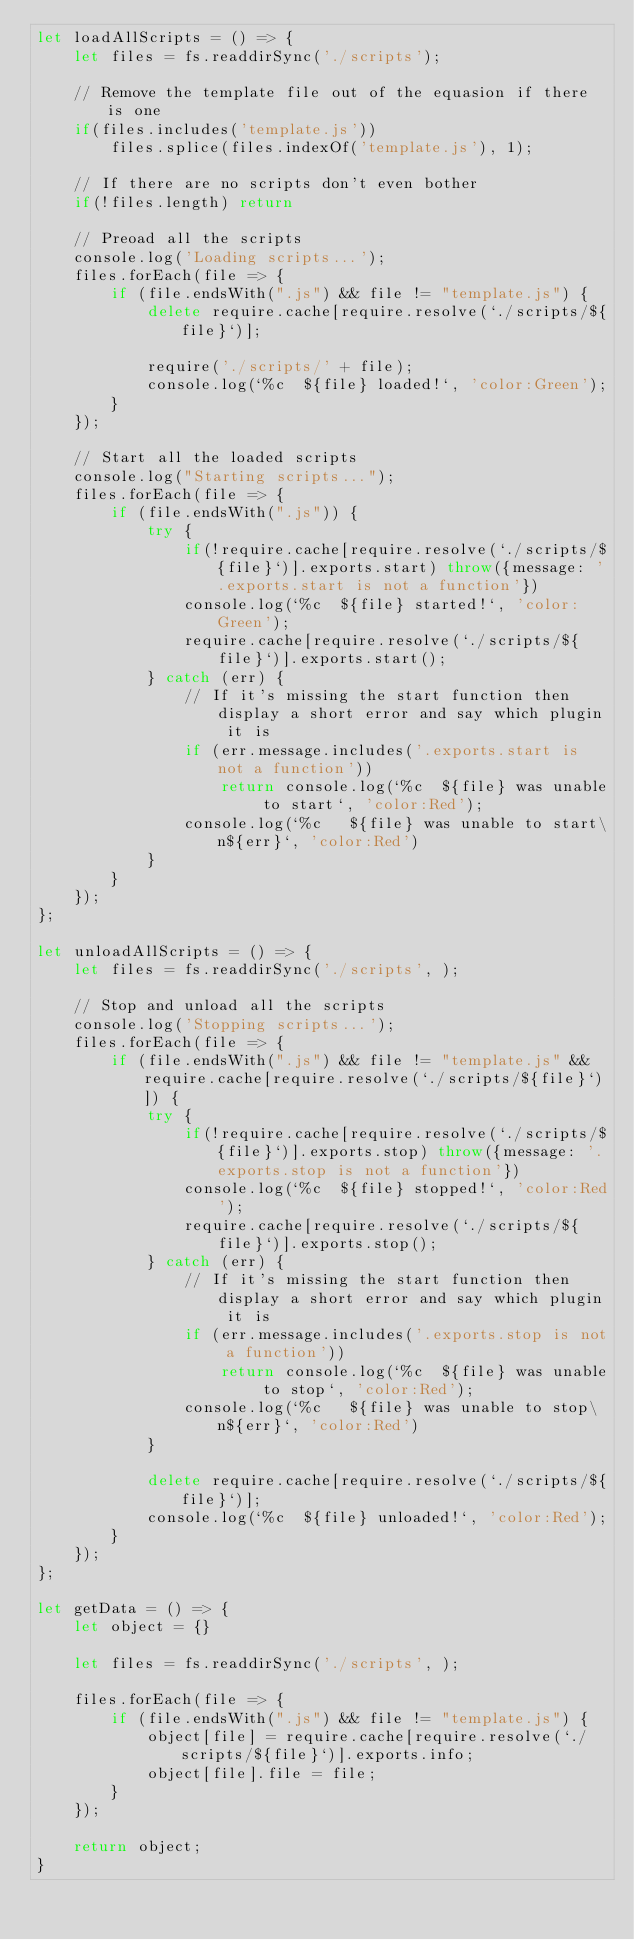<code> <loc_0><loc_0><loc_500><loc_500><_JavaScript_>let loadAllScripts = () => {
    let files = fs.readdirSync('./scripts');

    // Remove the template file out of the equasion if there is one
    if(files.includes('template.js'))
        files.splice(files.indexOf('template.js'), 1);

    // If there are no scripts don't even bother
    if(!files.length) return

    // Preoad all the scripts
    console.log('Loading scripts...');
    files.forEach(file => {
        if (file.endsWith(".js") && file != "template.js") {
            delete require.cache[require.resolve(`./scripts/${file}`)];

            require('./scripts/' + file);
            console.log(`%c  ${file} loaded!`, 'color:Green');
        }
    });

    // Start all the loaded scripts
    console.log("Starting scripts...");
    files.forEach(file => {
        if (file.endsWith(".js")) {
            try {
                if(!require.cache[require.resolve(`./scripts/${file}`)].exports.start) throw({message: '.exports.start is not a function'})
                console.log(`%c  ${file} started!`, 'color:Green');
                require.cache[require.resolve(`./scripts/${file}`)].exports.start();
            } catch (err) {
                // If it's missing the start function then display a short error and say which plugin it is
                if (err.message.includes('.exports.start is not a function'))
                    return console.log(`%c  ${file} was unable to start`, 'color:Red');
                console.log(`%c   ${file} was unable to start\n${err}`, 'color:Red')
            }
        }
    });
};

let unloadAllScripts = () => {
    let files = fs.readdirSync('./scripts', );

    // Stop and unload all the scripts
    console.log('Stopping scripts...');
    files.forEach(file => {
        if (file.endsWith(".js") && file != "template.js" && require.cache[require.resolve(`./scripts/${file}`)]) {
            try {
                if(!require.cache[require.resolve(`./scripts/${file}`)].exports.stop) throw({message: '.exports.stop is not a function'})
                console.log(`%c  ${file} stopped!`, 'color:Red');
                require.cache[require.resolve(`./scripts/${file}`)].exports.stop();
            } catch (err) {
                // If it's missing the start function then display a short error and say which plugin it is
                if (err.message.includes('.exports.stop is not a function'))
                    return console.log(`%c  ${file} was unable to stop`, 'color:Red');
                console.log(`%c   ${file} was unable to stop\n${err}`, 'color:Red')
            }

            delete require.cache[require.resolve(`./scripts/${file}`)];
            console.log(`%c  ${file} unloaded!`, 'color:Red');
        }
    });
};

let getData = () => {
    let object = {}

    let files = fs.readdirSync('./scripts', );

    files.forEach(file => {
        if (file.endsWith(".js") && file != "template.js") {
            object[file] = require.cache[require.resolve(`./scripts/${file}`)].exports.info;
            object[file].file = file;
        }
    });

    return object;
}</code> 